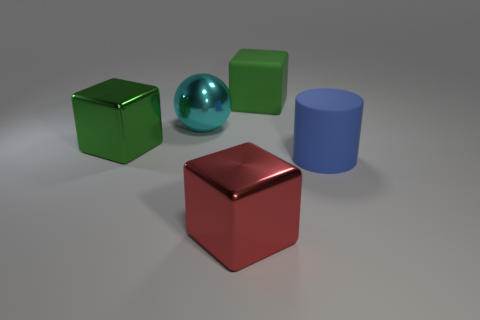Is there any pattern or symmetry in the arrangement of the objects? The objects are arranged without a clear pattern or symmetry. They are placed at varying distances from each other on a flat surface with the green and blue objects closer to each other and the red cube somewhat apart, giving a slight sense of balance in terms of color distribution.  What is the texture of the objects in the image? The objects in the image have a smooth and glossy texture. This is evident from the way the light reflects off their surfaces. The sphere, in particular, has a highly reflective surface that mirrors its surroundings, while the cubes and cylinder have a less reflective but still shiny finish. 